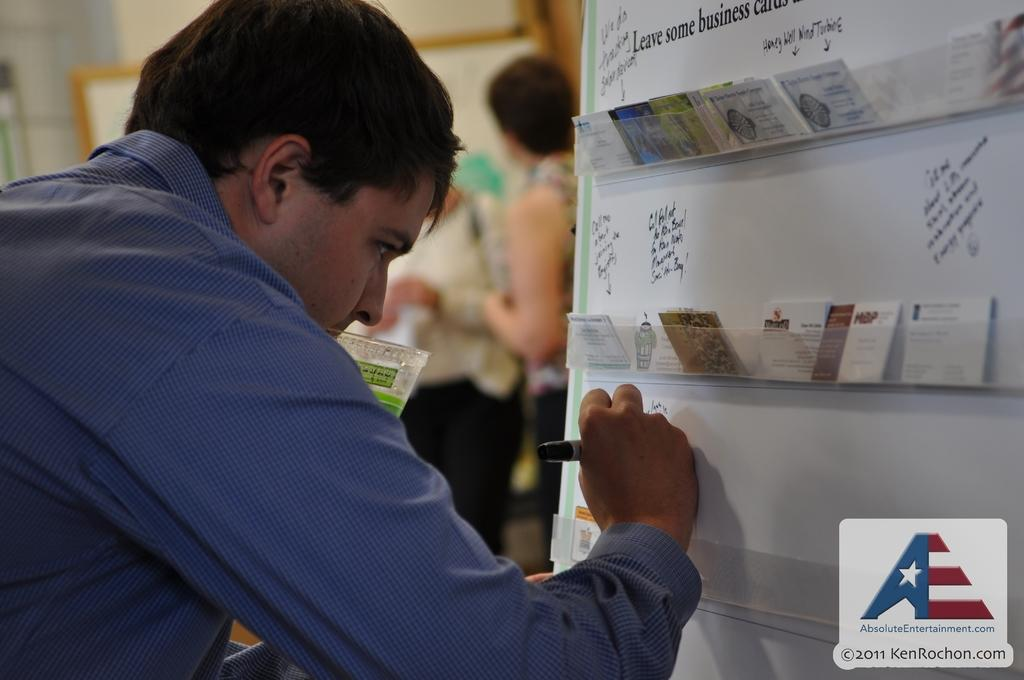<image>
Offer a succinct explanation of the picture presented. A man is working in an image labeled with the absoluteentertainment.com website. 